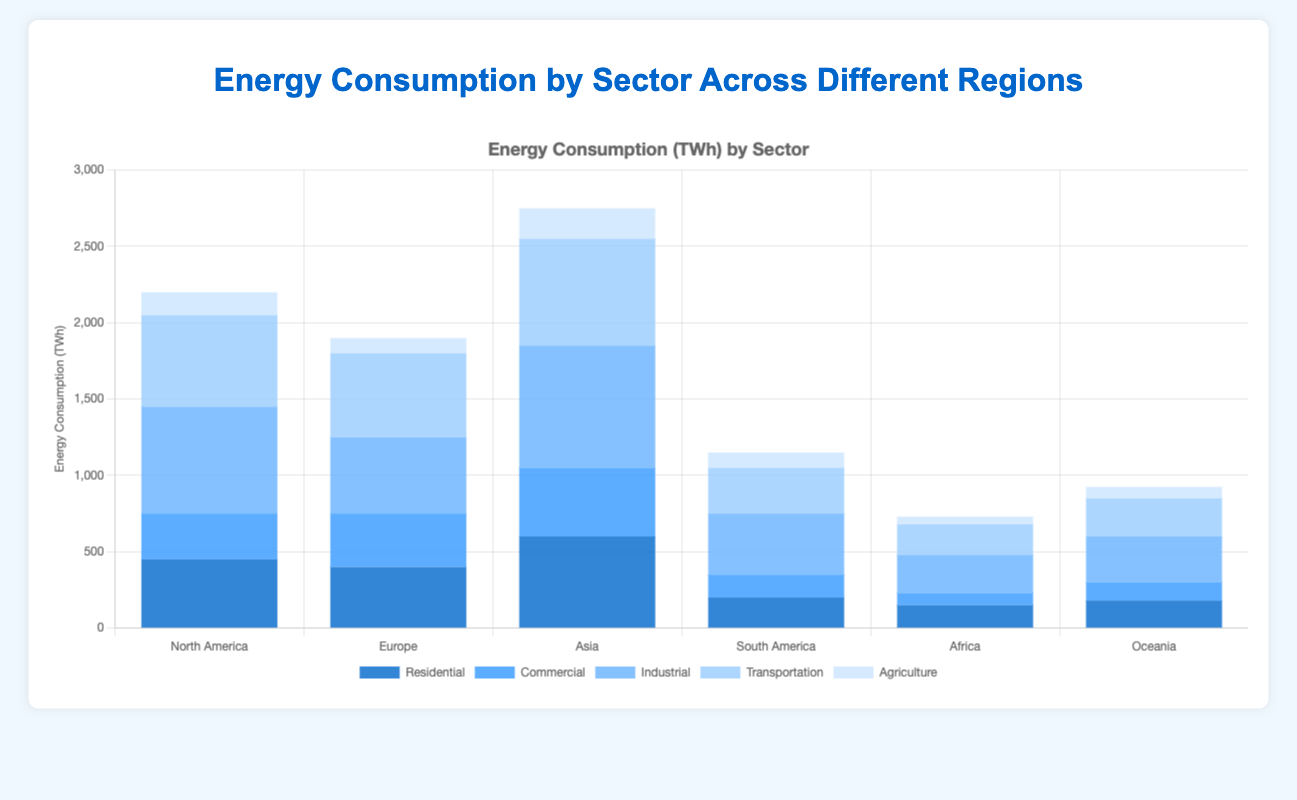Which region has the highest industrial energy consumption? The bar for "Industrial" in the "Asia" region is the tallest among all regions.
Answer: Asia Compare the residential energy consumption between North America and Europe. The "Residential" bar for North America is 450, while for Europe it is 400.
Answer: North America > Europe What is the total energy consumption for the Transportation sector across all regions? Sum up the "Transportation" values for all regions: 600 (North America) + 550 (Europe) + 700 (Asia) + 300 (South America) + 200 (Africa) + 250 (Oceania) = 2600.
Answer: 2600 Which region has the lowest commercial energy consumption? The "Commercial" bar for Africa is the shortest, valued at 80.
Answer: Africa What is the difference in industrial energy consumption between Asia and South America? The industrial energy consumption for Asia is 800 and for South America it is 400. The difference is 800 - 400 = 400.
Answer: 400 How does the agricultural energy consumption in Africa compare to that in Oceania? The "Agriculture" bar for Africa is 50, while for Oceania it is 75.
Answer: Africa < Oceania What is the average residential energy consumption across all regions? Sum of residential values: 450 + 400 + 600 + 200 + 150 + 180 = 1980. Average = 1980 / 6 = 330.
Answer: 330 Compare the total energy consumption of North America to Europe. North America: 450 (Residential) + 300 (Commercial) + 700 (Industrial) + 600 (Transportation) + 150 (Agriculture) = 2200. Europe: 400 (Residential) + 350 (Commercial) + 500 (Industrial) + 550 (Transportation) + 100 (Agriculture) = 1900.
Answer: North America > Europe 